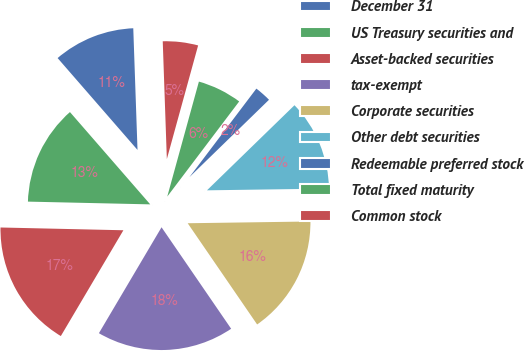<chart> <loc_0><loc_0><loc_500><loc_500><pie_chart><fcel>December 31<fcel>US Treasury securities and<fcel>Asset-backed securities<fcel>tax-exempt<fcel>Corporate securities<fcel>Other debt securities<fcel>Redeemable preferred stock<fcel>Total fixed maturity<fcel>Common stock<nl><fcel>10.84%<fcel>13.25%<fcel>16.86%<fcel>18.07%<fcel>15.66%<fcel>12.05%<fcel>2.42%<fcel>6.03%<fcel>4.83%<nl></chart> 